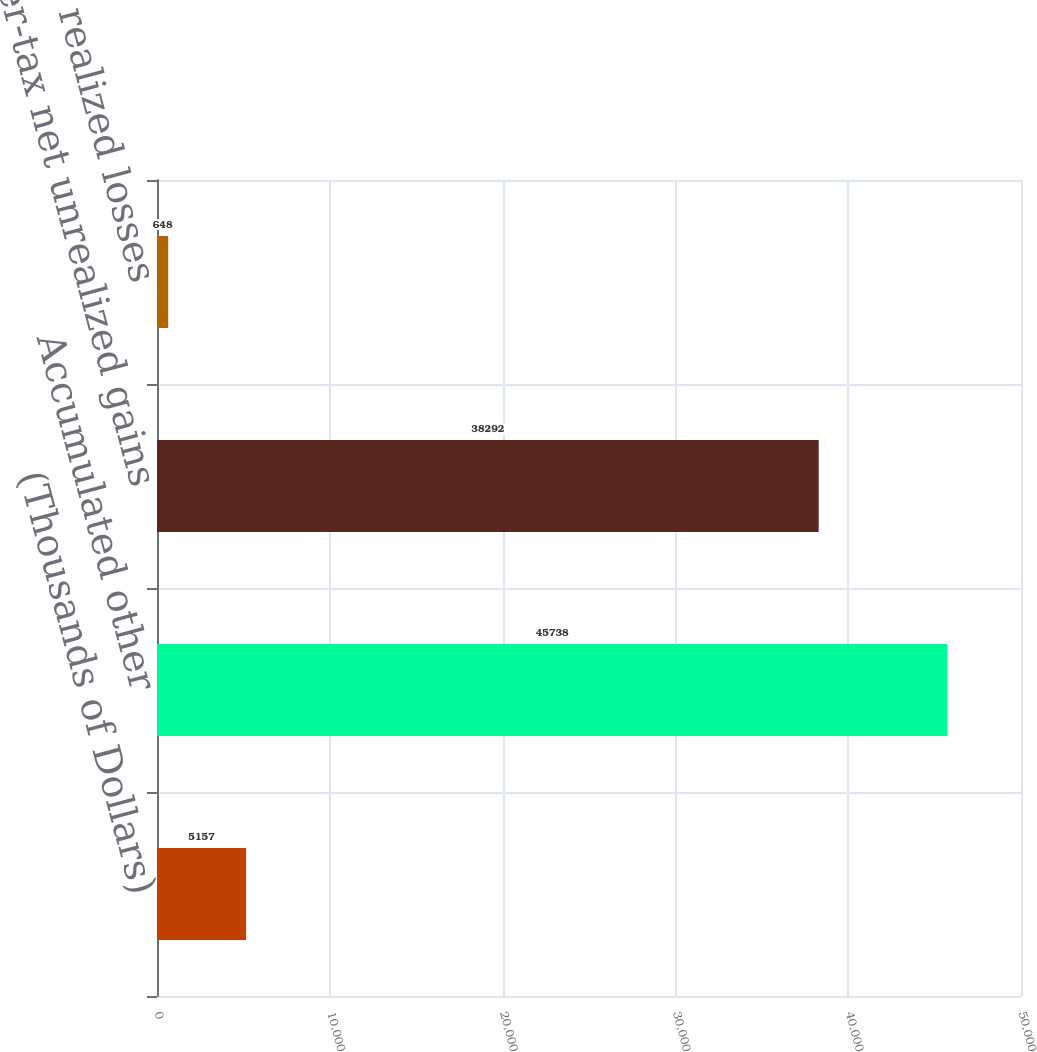Convert chart to OTSL. <chart><loc_0><loc_0><loc_500><loc_500><bar_chart><fcel>(Thousands of Dollars)<fcel>Accumulated other<fcel>After-tax net unrealized gains<fcel>After-tax net realized losses<nl><fcel>5157<fcel>45738<fcel>38292<fcel>648<nl></chart> 